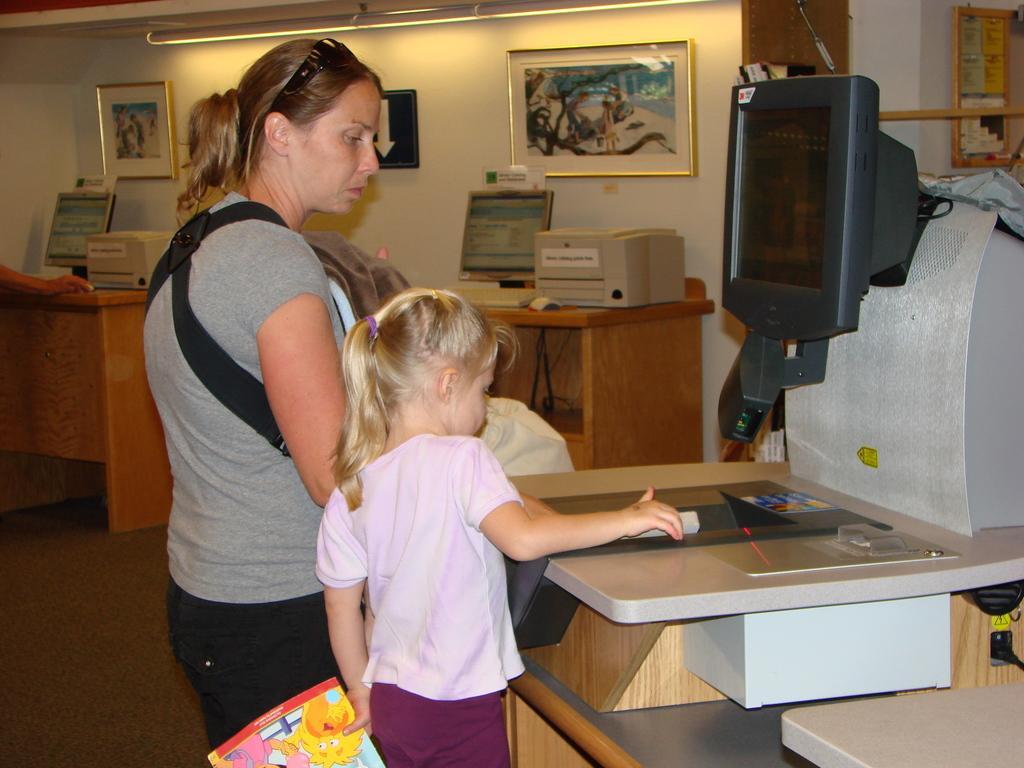Please provide a concise description of this image. On the background we can see wall, few frames over a wall. Here we can see tables and on the table we can see screens and some machines. We can see one women and a girl standing in front of a table. This girl is holding a book in her hand. This is a floor. We can see person's hand on the table. 